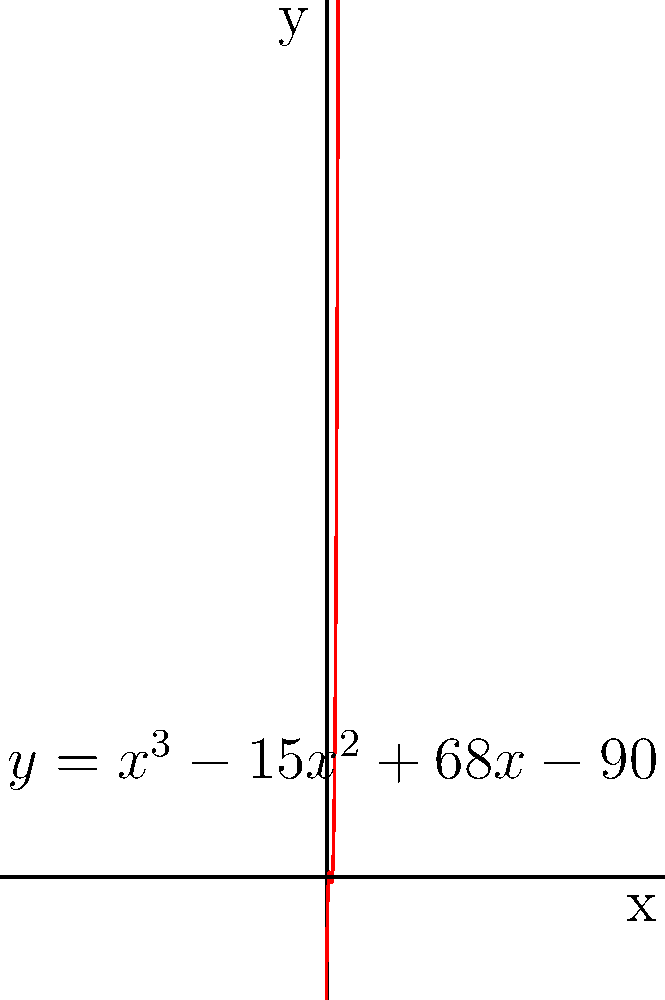As a foster parent, you've welcomed three children into your home. Their ages, in years, are represented by the roots of the polynomial equation $y = x^3 - 15x^2 + 68x - 90$. What is the age of the oldest foster child in your care? To find the age of the oldest foster child, we need to determine the largest root of the given polynomial equation. Let's approach this step-by-step:

1) The polynomial equation is $y = x^3 - 15x^2 + 68x - 90$

2) To find the roots, we need to set $y = 0$:
   $0 = x^3 - 15x^2 + 68x - 90$

3) This cubic equation is difficult to solve by factoring. However, we can use the rational root theorem to find potential rational roots.

4) The potential rational roots are the factors of the constant term (90):
   $\pm 1, \pm 2, \pm 3, \pm 5, \pm 6, \pm 9, \pm 10, \pm 15, \pm 18, \pm 30, \pm 45, \pm 90$

5) By testing these values, we find that 5, 6, and 9 are roots of the equation.

6) We can verify this by substituting these values into the original equation:
   For $x = 5$: $5^3 - 15(5^2) + 68(5) - 90 = 125 - 375 + 340 - 90 = 0$
   For $x = 6$: $6^3 - 15(6^2) + 68(6) - 90 = 216 - 540 + 408 - 90 = 0$
   For $x = 9$: $9^3 - 15(9^2) + 68(9) - 90 = 729 - 1215 + 612 - 90 = 0$

7) The largest root is 9, which represents the age of the oldest foster child.
Answer: 9 years old 